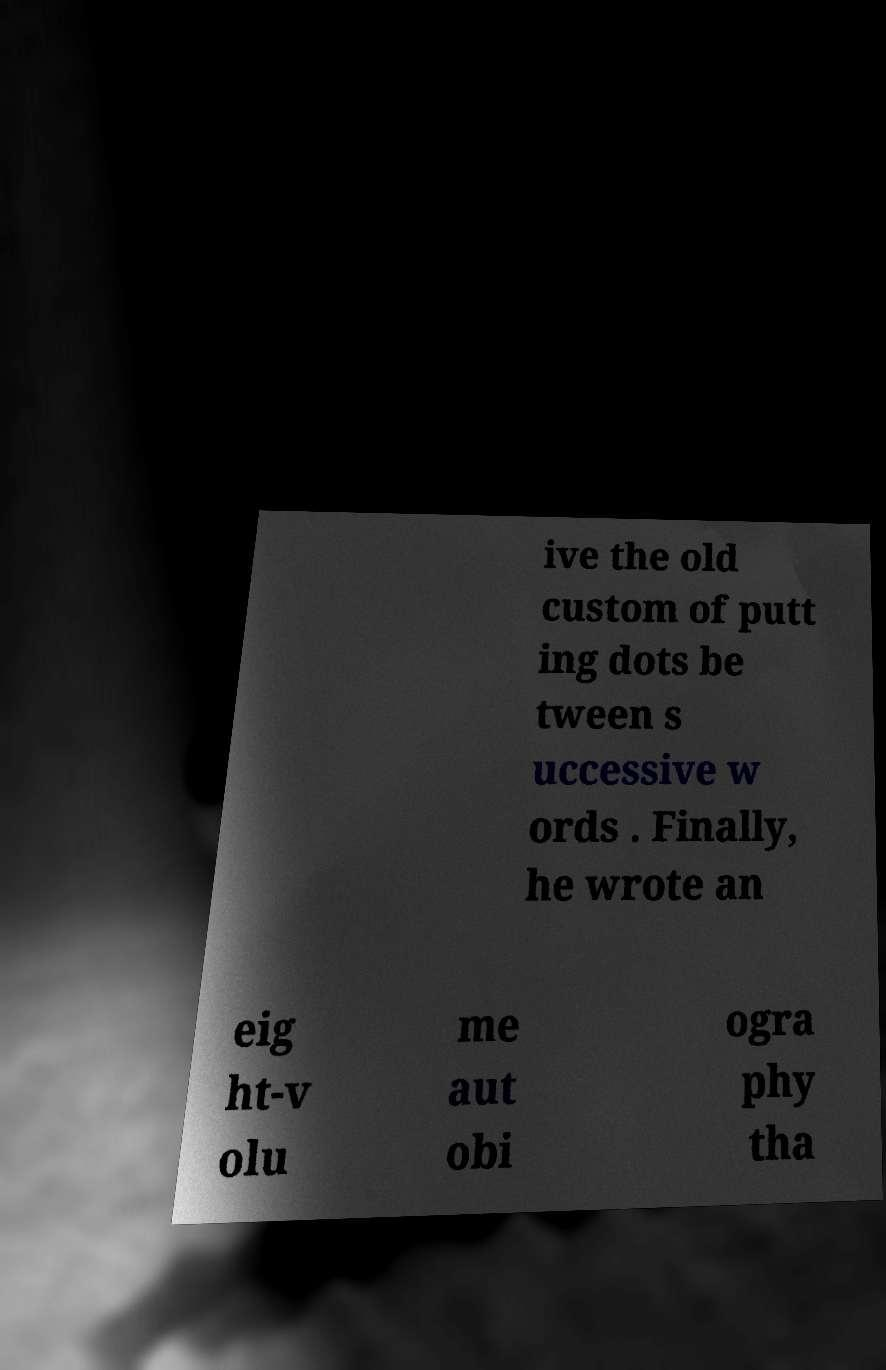For documentation purposes, I need the text within this image transcribed. Could you provide that? ive the old custom of putt ing dots be tween s uccessive w ords . Finally, he wrote an eig ht-v olu me aut obi ogra phy tha 